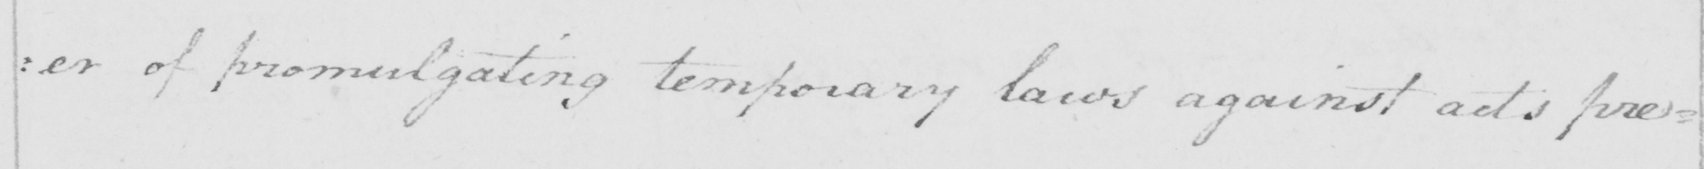Transcribe the text shown in this historical manuscript line. : er of promulgating temporary laws against acts prejudicial 